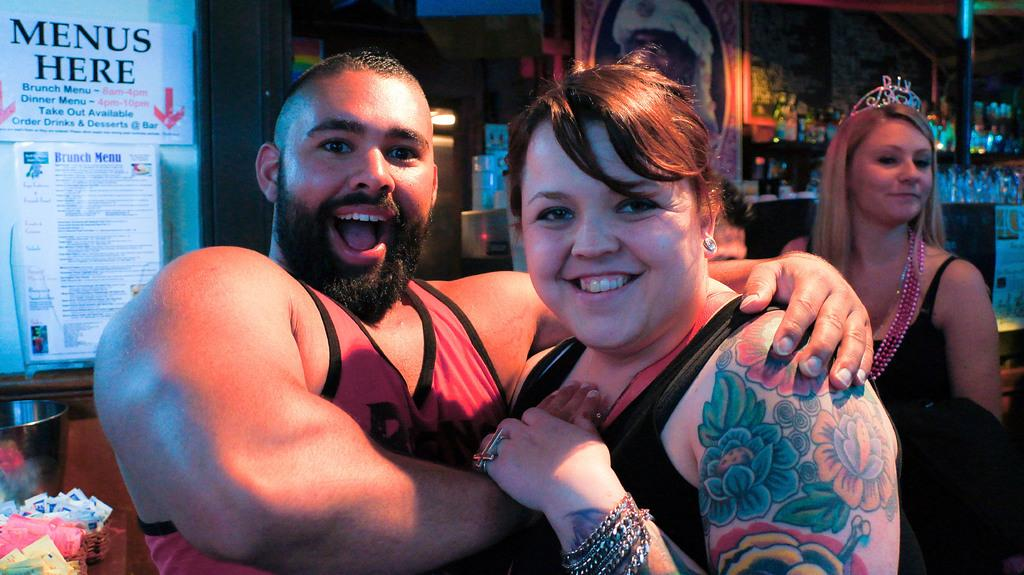What can be seen in the background of the image? There are bottles in the background of the image, and they are in racks. What is located on the left side of the image? There are posters on the left side of the image. How many people are present in the image? There are two people, a man and a woman, present in the image, and there is another woman visible behind them. What type of mask is the man wearing in the image? There is no mask present in the image; the man is not wearing one. Can you see any trains in the image? There are no trains visible in the image. 